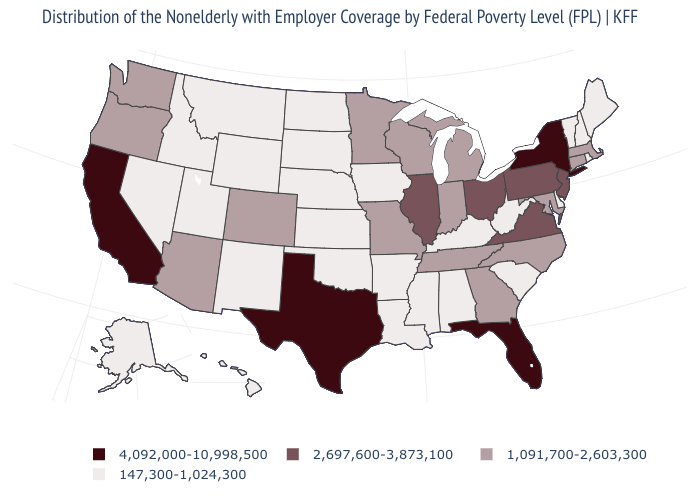Name the states that have a value in the range 147,300-1,024,300?
Keep it brief. Alabama, Alaska, Arkansas, Delaware, Hawaii, Idaho, Iowa, Kansas, Kentucky, Louisiana, Maine, Mississippi, Montana, Nebraska, Nevada, New Hampshire, New Mexico, North Dakota, Oklahoma, Rhode Island, South Carolina, South Dakota, Utah, Vermont, West Virginia, Wyoming. Does the map have missing data?
Be succinct. No. Among the states that border Wyoming , which have the lowest value?
Concise answer only. Idaho, Montana, Nebraska, South Dakota, Utah. Does the first symbol in the legend represent the smallest category?
Be succinct. No. Name the states that have a value in the range 4,092,000-10,998,500?
Answer briefly. California, Florida, New York, Texas. Name the states that have a value in the range 2,697,600-3,873,100?
Be succinct. Illinois, New Jersey, Ohio, Pennsylvania, Virginia. What is the highest value in states that border Vermont?
Keep it brief. 4,092,000-10,998,500. Does Texas have the highest value in the USA?
Give a very brief answer. Yes. What is the value of Mississippi?
Write a very short answer. 147,300-1,024,300. Name the states that have a value in the range 1,091,700-2,603,300?
Give a very brief answer. Arizona, Colorado, Connecticut, Georgia, Indiana, Maryland, Massachusetts, Michigan, Minnesota, Missouri, North Carolina, Oregon, Tennessee, Washington, Wisconsin. What is the lowest value in states that border Nevada?
Answer briefly. 147,300-1,024,300. Does Georgia have a lower value than Texas?
Give a very brief answer. Yes. What is the value of Virginia?
Give a very brief answer. 2,697,600-3,873,100. What is the value of Iowa?
Concise answer only. 147,300-1,024,300. What is the lowest value in the South?
Answer briefly. 147,300-1,024,300. 